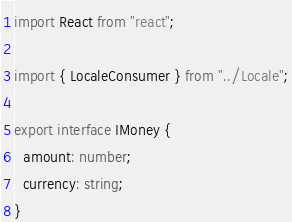Convert code to text. <code><loc_0><loc_0><loc_500><loc_500><_TypeScript_>import React from "react";

import { LocaleConsumer } from "../Locale";

export interface IMoney {
  amount: number;
  currency: string;
}</code> 